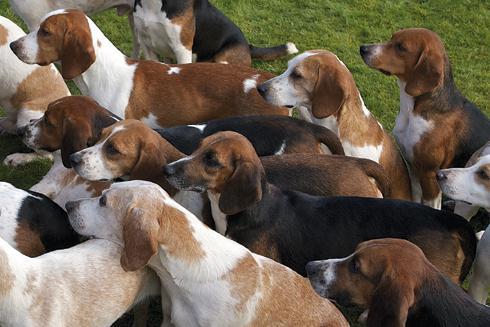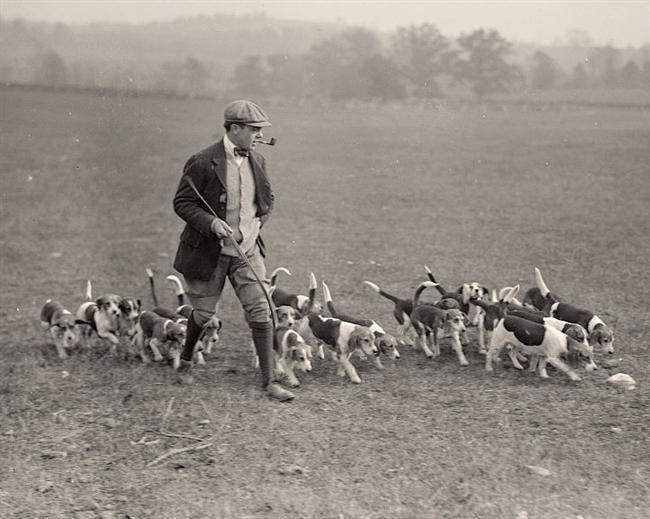The first image is the image on the left, the second image is the image on the right. Examine the images to the left and right. Is the description "No humans are in sight in one of the images of hounds." accurate? Answer yes or no. Yes. The first image is the image on the left, the second image is the image on the right. Evaluate the accuracy of this statement regarding the images: "The picture on the right is in black and white.". Is it true? Answer yes or no. Yes. 